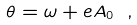<formula> <loc_0><loc_0><loc_500><loc_500>\theta = \omega + e A _ { 0 } \ ,</formula> 